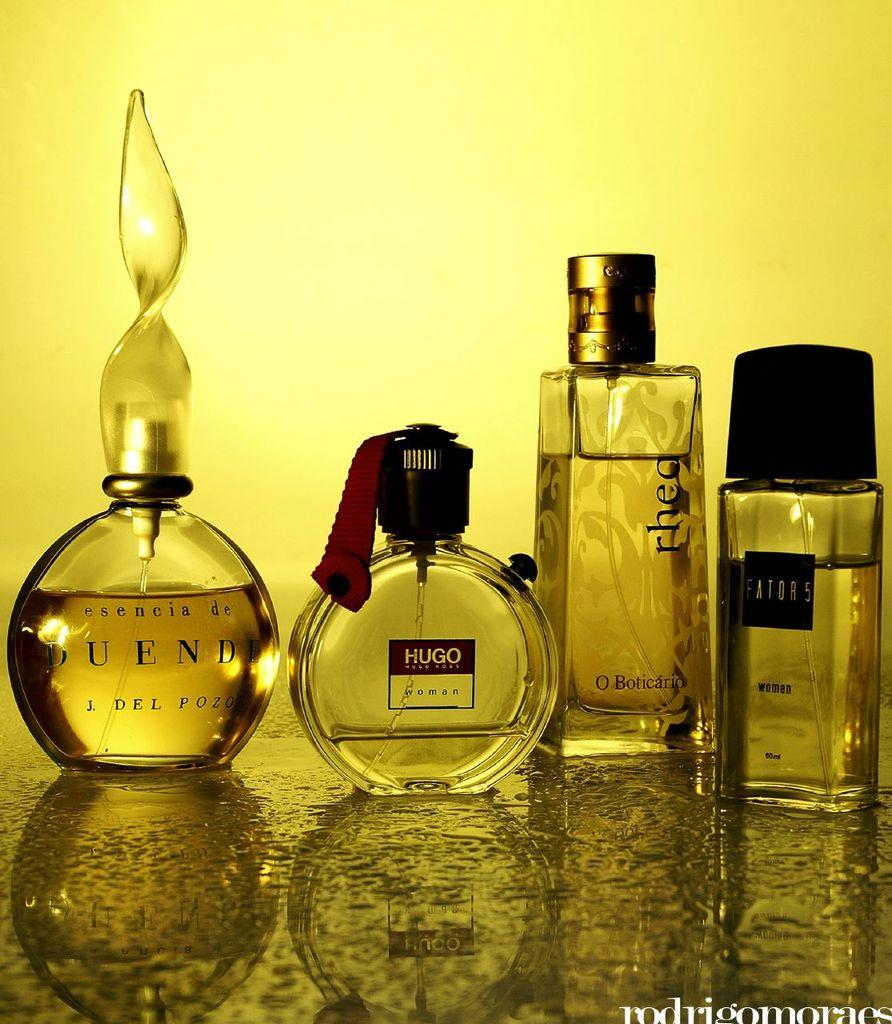<image>
Present a compact description of the photo's key features. Four bottles of perfume sit on a counter with one being HUGO Woman. 